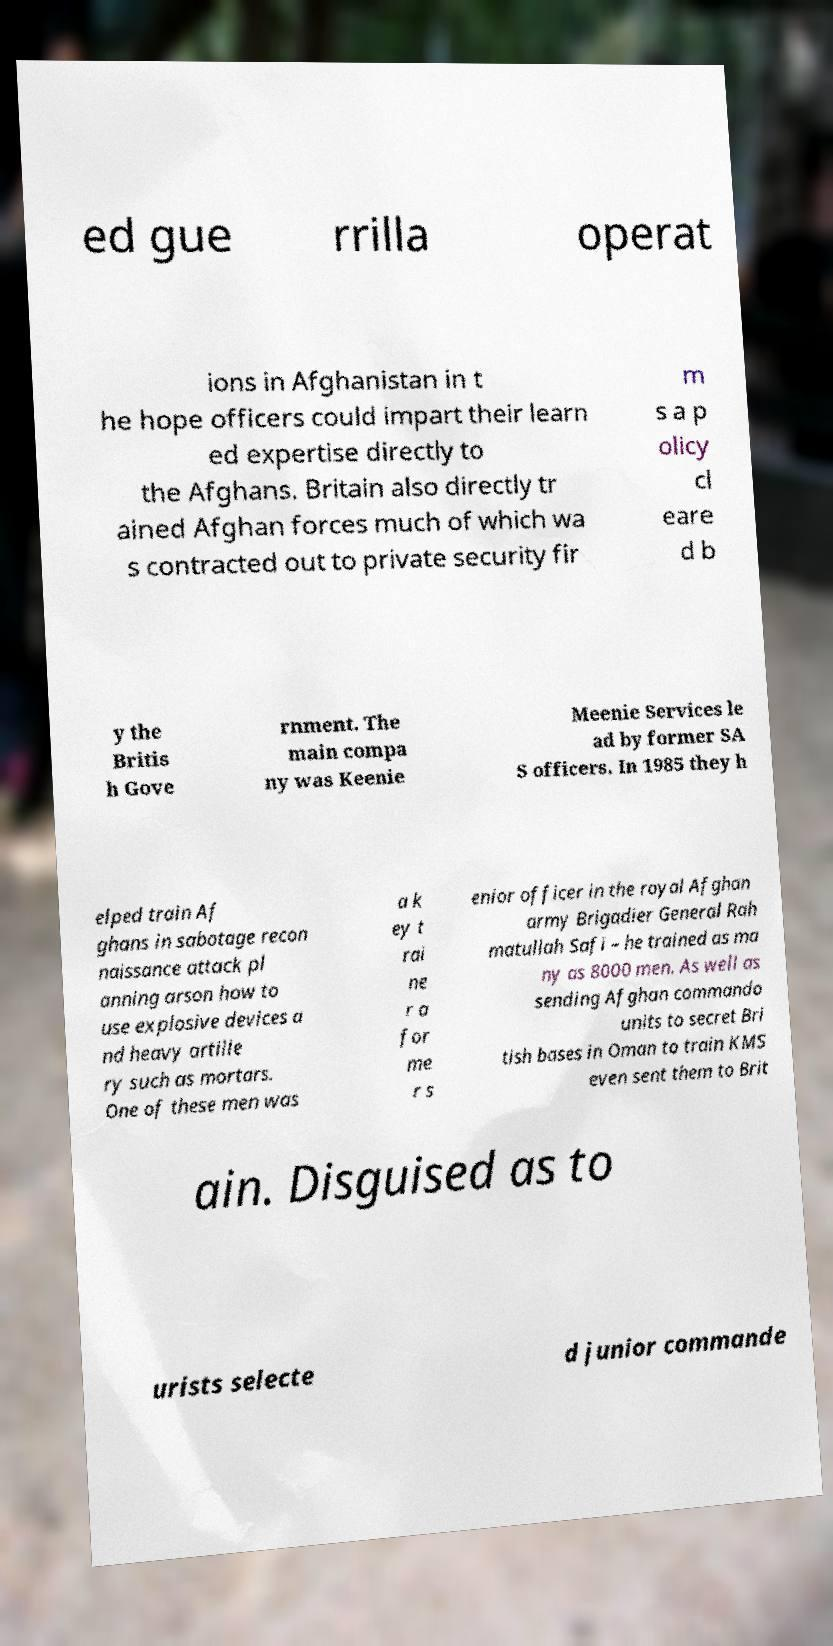I need the written content from this picture converted into text. Can you do that? ed gue rrilla operat ions in Afghanistan in t he hope officers could impart their learn ed expertise directly to the Afghans. Britain also directly tr ained Afghan forces much of which wa s contracted out to private security fir m s a p olicy cl eare d b y the Britis h Gove rnment. The main compa ny was Keenie Meenie Services le ad by former SA S officers. In 1985 they h elped train Af ghans in sabotage recon naissance attack pl anning arson how to use explosive devices a nd heavy artille ry such as mortars. One of these men was a k ey t rai ne r a for me r s enior officer in the royal Afghan army Brigadier General Rah matullah Safi – he trained as ma ny as 8000 men. As well as sending Afghan commando units to secret Bri tish bases in Oman to train KMS even sent them to Brit ain. Disguised as to urists selecte d junior commande 